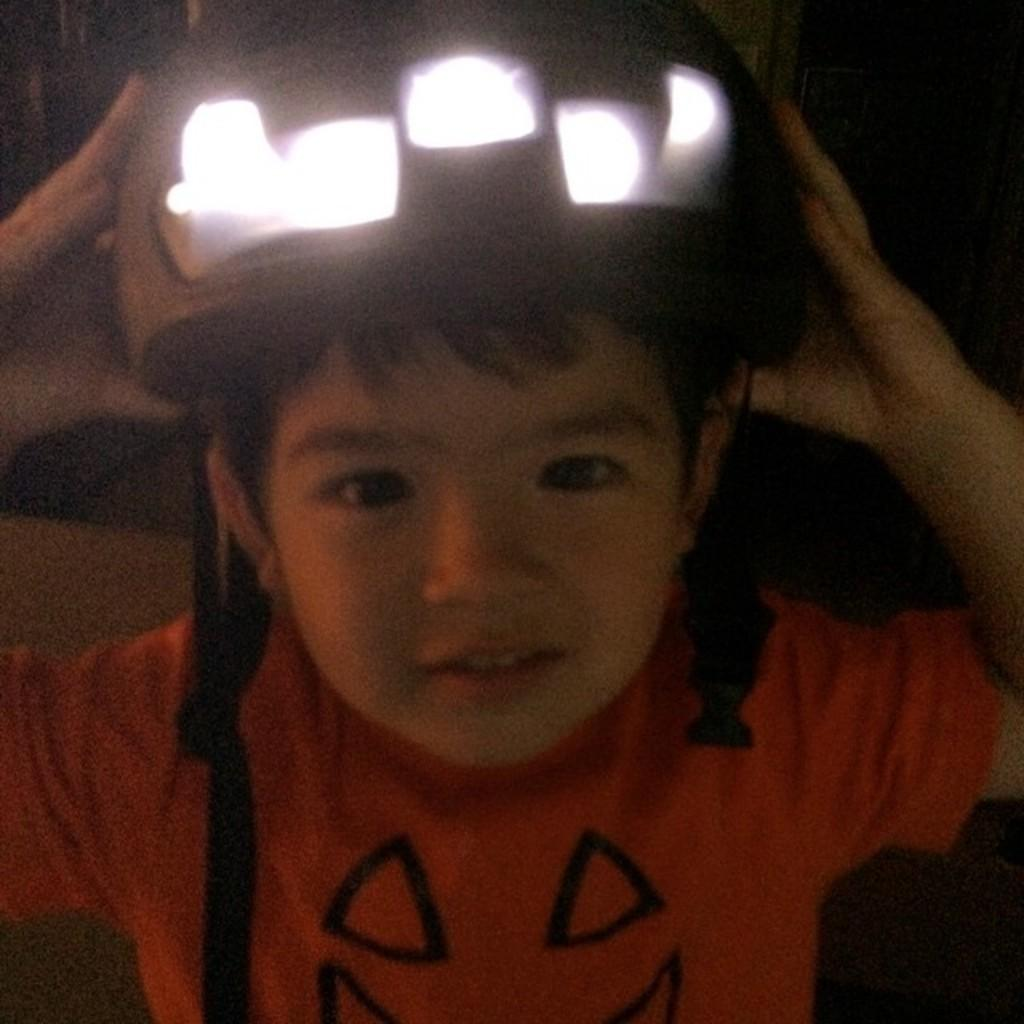What is the main subject of the image? There is a person in the image. What is the person holding in the image? The person is holding a helmet. What feature can be observed on the helmet? There are lights fixed inside the helmet. What type of instrument is the beast playing in the image? There is no beast or instrument present in the image. 